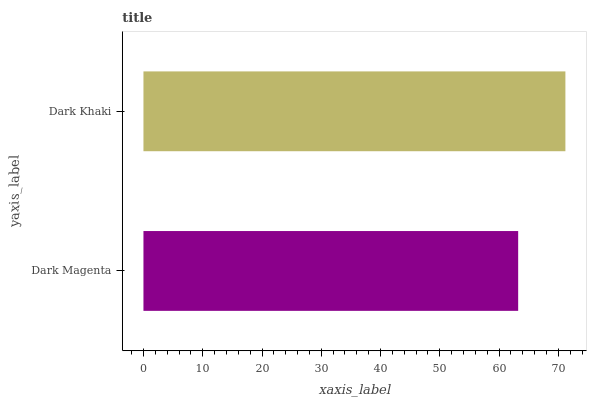Is Dark Magenta the minimum?
Answer yes or no. Yes. Is Dark Khaki the maximum?
Answer yes or no. Yes. Is Dark Khaki the minimum?
Answer yes or no. No. Is Dark Khaki greater than Dark Magenta?
Answer yes or no. Yes. Is Dark Magenta less than Dark Khaki?
Answer yes or no. Yes. Is Dark Magenta greater than Dark Khaki?
Answer yes or no. No. Is Dark Khaki less than Dark Magenta?
Answer yes or no. No. Is Dark Khaki the high median?
Answer yes or no. Yes. Is Dark Magenta the low median?
Answer yes or no. Yes. Is Dark Magenta the high median?
Answer yes or no. No. Is Dark Khaki the low median?
Answer yes or no. No. 